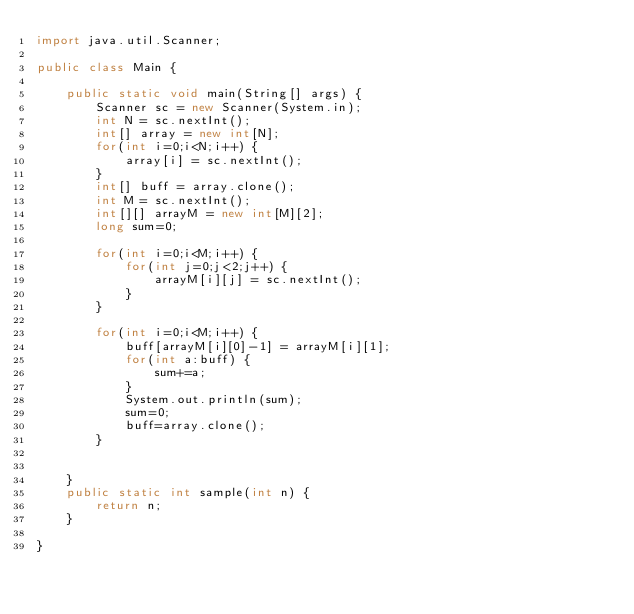<code> <loc_0><loc_0><loc_500><loc_500><_Java_>import java.util.Scanner;

public class Main {

	public static void main(String[] args) {
		Scanner sc = new Scanner(System.in);
		int N = sc.nextInt();
		int[] array = new int[N];
		for(int i=0;i<N;i++) {
			array[i] = sc.nextInt();
		}
		int[] buff = array.clone();
		int M = sc.nextInt();
		int[][] arrayM = new int[M][2];
		long sum=0;

		for(int i=0;i<M;i++) {
			for(int j=0;j<2;j++) {
				arrayM[i][j] = sc.nextInt();
			}
		}

		for(int i=0;i<M;i++) {
			buff[arrayM[i][0]-1] = arrayM[i][1];
			for(int a:buff) {
				sum+=a;
			}
			System.out.println(sum);
			sum=0;
			buff=array.clone();
		}


	}
	public static int sample(int n) {
		return n;
	}

}
</code> 